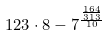Convert formula to latex. <formula><loc_0><loc_0><loc_500><loc_500>1 2 3 \cdot 8 - 7 ^ { \frac { \frac { 1 6 4 } { 3 1 3 } } { 1 0 } }</formula> 